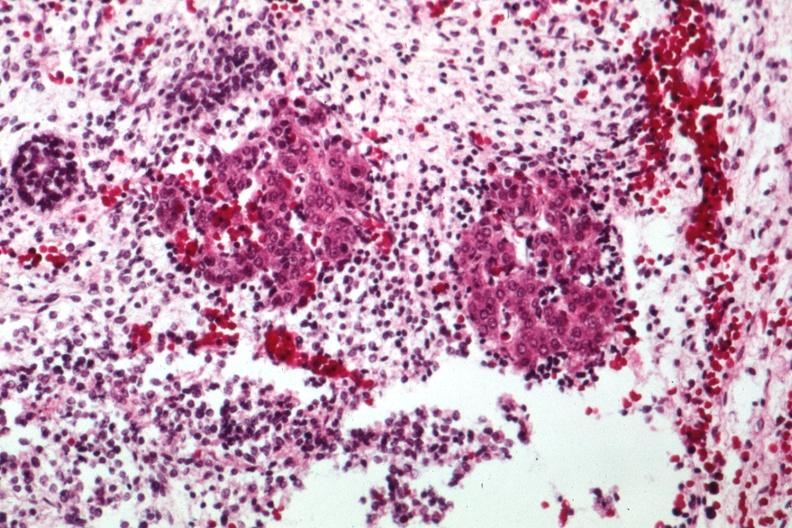does this image show acinar tissue looking like pancreas with primitive stroma?
Answer the question using a single word or phrase. Yes 